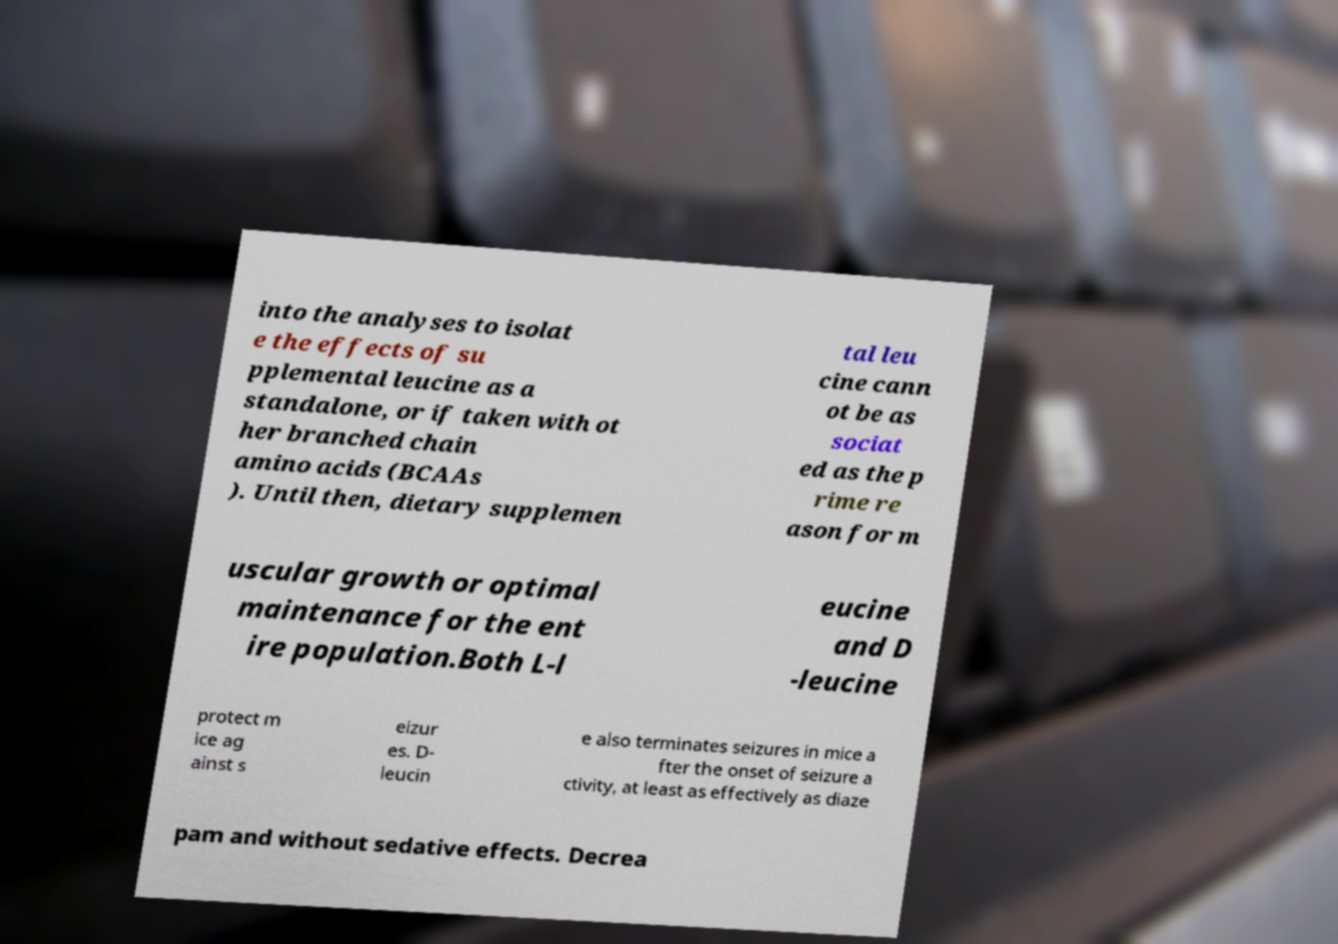Could you assist in decoding the text presented in this image and type it out clearly? into the analyses to isolat e the effects of su pplemental leucine as a standalone, or if taken with ot her branched chain amino acids (BCAAs ). Until then, dietary supplemen tal leu cine cann ot be as sociat ed as the p rime re ason for m uscular growth or optimal maintenance for the ent ire population.Both L-l eucine and D -leucine protect m ice ag ainst s eizur es. D- leucin e also terminates seizures in mice a fter the onset of seizure a ctivity, at least as effectively as diaze pam and without sedative effects. Decrea 